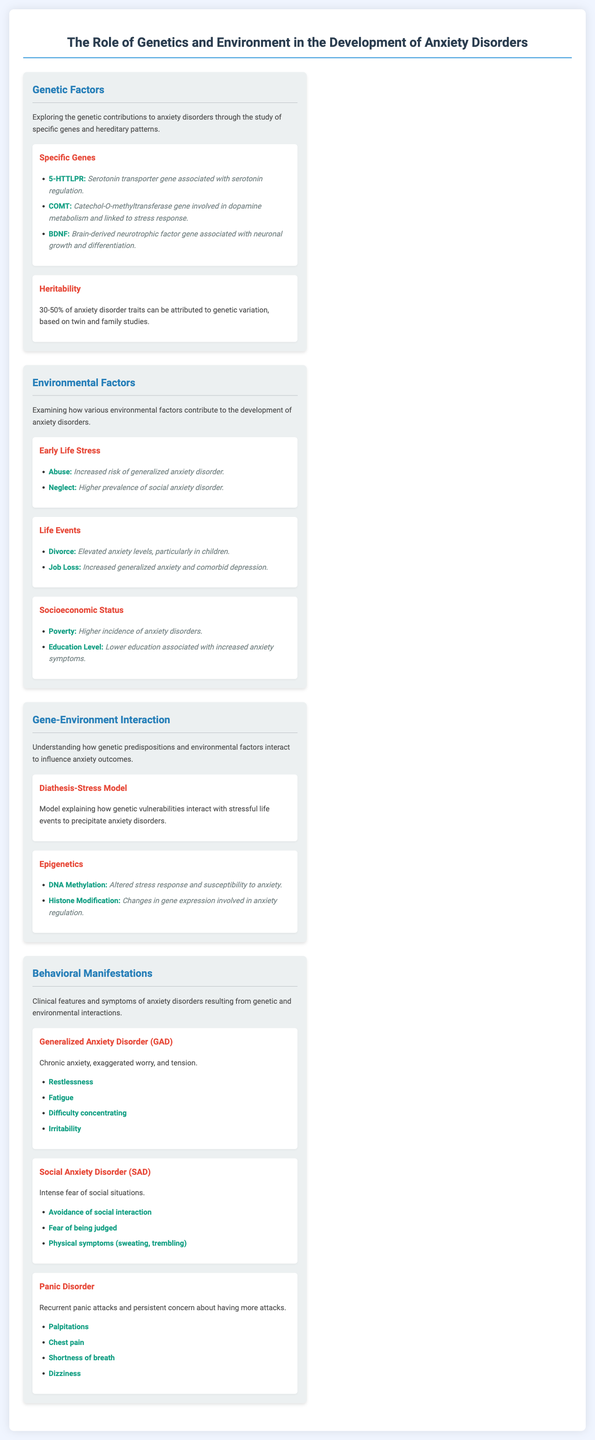What gene is associated with serotonin regulation? The gene known for its role in serotonin regulation is 5-HTTLPR.
Answer: 5-HTTLPR What percentage of anxiety disorder traits can be attributed to genetic variation? According to the document, 30-50% of anxiety disorder traits are attributed to genetic variation.
Answer: 30-50% What is the impact of early life abuse on anxiety disorders? The document states that abuse increases the risk of generalized anxiety disorder.
Answer: Increased risk of generalized anxiety disorder What model explains the interaction of genetic vulnerabilities with stressful life events? The Diathesis-Stress Model explains the interaction of genetic vulnerabilities with stressful life events.
Answer: Diathesis-Stress Model What symptom is associated with Panic Disorder? The document lists palpitations as a symptom of Panic Disorder.
Answer: Palpitations How does lower education level relate to anxiety? The document suggests that lower education is associated with increased anxiety symptoms.
Answer: Increased anxiety symptoms What gene is linked to stress response through dopamine metabolism? The COMT gene is involved in dopamine metabolism and is linked to stress response.
Answer: COMT What environmental factor is linked to a higher incidence of anxiety disorders? Poverty is identified as an environmental factor correlating with a higher incidence of anxiety disorders.
Answer: Poverty What behavioral manifestation involves avoidance of social interaction? The document identifies Social Anxiety Disorder as involving avoidance of social interaction.
Answer: Social Anxiety Disorder 